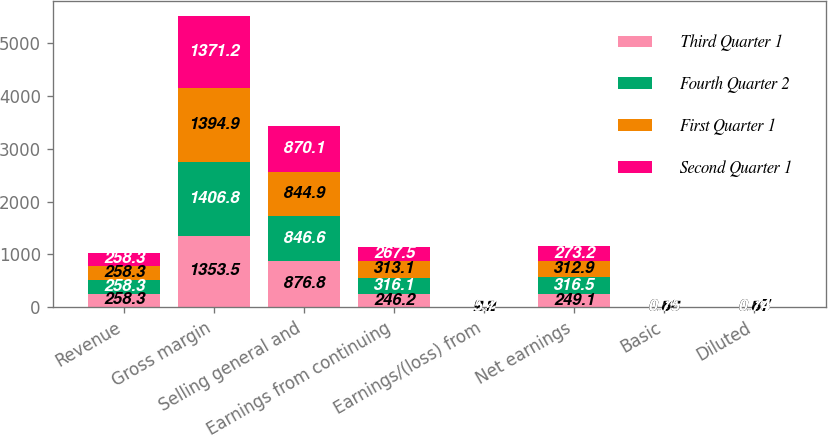<chart> <loc_0><loc_0><loc_500><loc_500><stacked_bar_chart><ecel><fcel>Revenue<fcel>Gross margin<fcel>Selling general and<fcel>Earnings from continuing<fcel>Earnings/(loss) from<fcel>Net earnings<fcel>Basic<fcel>Diluted<nl><fcel>Third Quarter 1<fcel>258.3<fcel>1353.5<fcel>876.8<fcel>246.2<fcel>2.9<fcel>249.1<fcel>0.69<fcel>0.68<nl><fcel>Fourth Quarter 2<fcel>258.3<fcel>1406.8<fcel>846.6<fcel>316.1<fcel>0.4<fcel>316.5<fcel>0.89<fcel>0.88<nl><fcel>First Quarter 1<fcel>258.3<fcel>1394.9<fcel>844.9<fcel>313.1<fcel>0.2<fcel>312.9<fcel>0.88<fcel>0.87<nl><fcel>Second Quarter 1<fcel>258.3<fcel>1371.2<fcel>870.1<fcel>267.5<fcel>5.7<fcel>273.2<fcel>0.75<fcel>0.74<nl></chart> 